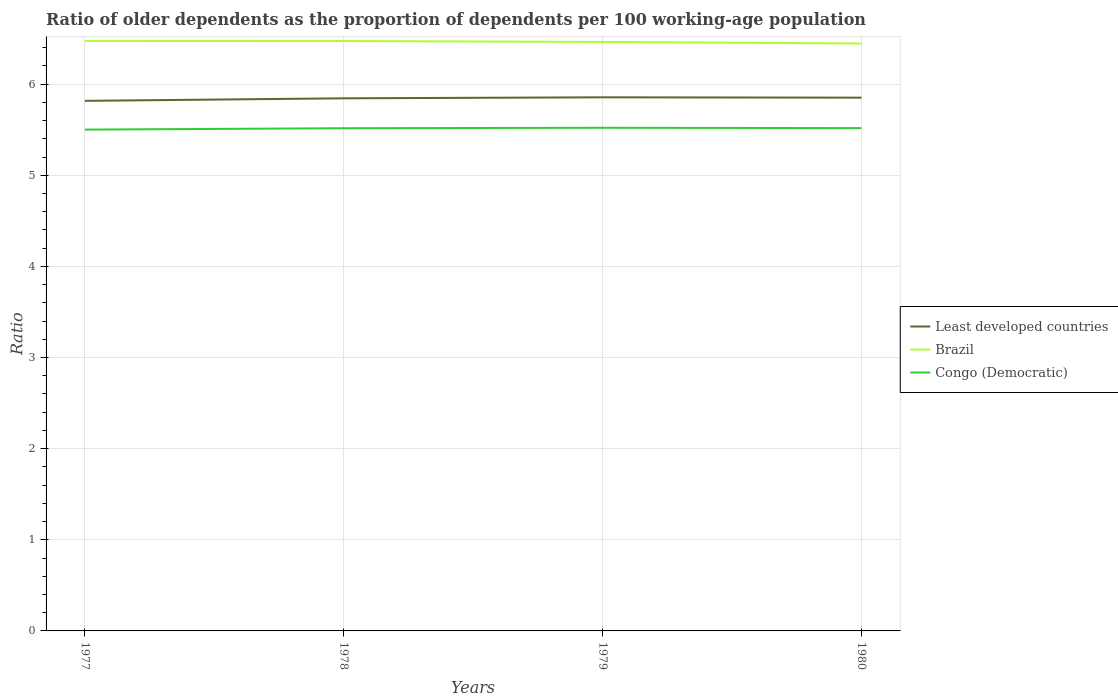How many different coloured lines are there?
Make the answer very short. 3. Across all years, what is the maximum age dependency ratio(old) in Least developed countries?
Ensure brevity in your answer.  5.82. What is the total age dependency ratio(old) in Least developed countries in the graph?
Give a very brief answer. -0.01. What is the difference between the highest and the second highest age dependency ratio(old) in Congo (Democratic)?
Give a very brief answer. 0.02. How many lines are there?
Your answer should be compact. 3. Are the values on the major ticks of Y-axis written in scientific E-notation?
Keep it short and to the point. No. Does the graph contain grids?
Offer a terse response. Yes. What is the title of the graph?
Your answer should be very brief. Ratio of older dependents as the proportion of dependents per 100 working-age population. What is the label or title of the Y-axis?
Provide a succinct answer. Ratio. What is the Ratio of Least developed countries in 1977?
Ensure brevity in your answer.  5.82. What is the Ratio in Brazil in 1977?
Ensure brevity in your answer.  6.47. What is the Ratio in Congo (Democratic) in 1977?
Your response must be concise. 5.5. What is the Ratio in Least developed countries in 1978?
Your answer should be very brief. 5.84. What is the Ratio in Brazil in 1978?
Your response must be concise. 6.47. What is the Ratio in Congo (Democratic) in 1978?
Keep it short and to the point. 5.52. What is the Ratio in Least developed countries in 1979?
Make the answer very short. 5.86. What is the Ratio of Brazil in 1979?
Give a very brief answer. 6.46. What is the Ratio in Congo (Democratic) in 1979?
Your response must be concise. 5.52. What is the Ratio of Least developed countries in 1980?
Provide a short and direct response. 5.85. What is the Ratio in Brazil in 1980?
Provide a short and direct response. 6.45. What is the Ratio in Congo (Democratic) in 1980?
Keep it short and to the point. 5.52. Across all years, what is the maximum Ratio of Least developed countries?
Offer a terse response. 5.86. Across all years, what is the maximum Ratio in Brazil?
Ensure brevity in your answer.  6.47. Across all years, what is the maximum Ratio in Congo (Democratic)?
Offer a very short reply. 5.52. Across all years, what is the minimum Ratio of Least developed countries?
Offer a very short reply. 5.82. Across all years, what is the minimum Ratio in Brazil?
Give a very brief answer. 6.45. Across all years, what is the minimum Ratio in Congo (Democratic)?
Your response must be concise. 5.5. What is the total Ratio of Least developed countries in the graph?
Offer a terse response. 23.37. What is the total Ratio of Brazil in the graph?
Keep it short and to the point. 25.86. What is the total Ratio in Congo (Democratic) in the graph?
Give a very brief answer. 22.06. What is the difference between the Ratio in Least developed countries in 1977 and that in 1978?
Make the answer very short. -0.03. What is the difference between the Ratio of Brazil in 1977 and that in 1978?
Keep it short and to the point. 0. What is the difference between the Ratio of Congo (Democratic) in 1977 and that in 1978?
Keep it short and to the point. -0.02. What is the difference between the Ratio in Least developed countries in 1977 and that in 1979?
Provide a succinct answer. -0.04. What is the difference between the Ratio of Brazil in 1977 and that in 1979?
Provide a short and direct response. 0.01. What is the difference between the Ratio in Congo (Democratic) in 1977 and that in 1979?
Provide a succinct answer. -0.02. What is the difference between the Ratio in Least developed countries in 1977 and that in 1980?
Make the answer very short. -0.04. What is the difference between the Ratio of Brazil in 1977 and that in 1980?
Keep it short and to the point. 0.03. What is the difference between the Ratio of Congo (Democratic) in 1977 and that in 1980?
Keep it short and to the point. -0.02. What is the difference between the Ratio of Least developed countries in 1978 and that in 1979?
Your answer should be very brief. -0.01. What is the difference between the Ratio of Brazil in 1978 and that in 1979?
Offer a terse response. 0.01. What is the difference between the Ratio of Congo (Democratic) in 1978 and that in 1979?
Offer a terse response. -0. What is the difference between the Ratio in Least developed countries in 1978 and that in 1980?
Your answer should be very brief. -0.01. What is the difference between the Ratio of Brazil in 1978 and that in 1980?
Provide a succinct answer. 0.03. What is the difference between the Ratio of Congo (Democratic) in 1978 and that in 1980?
Your response must be concise. -0. What is the difference between the Ratio of Least developed countries in 1979 and that in 1980?
Keep it short and to the point. 0. What is the difference between the Ratio of Brazil in 1979 and that in 1980?
Provide a short and direct response. 0.02. What is the difference between the Ratio in Congo (Democratic) in 1979 and that in 1980?
Your answer should be compact. 0. What is the difference between the Ratio of Least developed countries in 1977 and the Ratio of Brazil in 1978?
Make the answer very short. -0.66. What is the difference between the Ratio in Least developed countries in 1977 and the Ratio in Congo (Democratic) in 1978?
Provide a short and direct response. 0.3. What is the difference between the Ratio of Least developed countries in 1977 and the Ratio of Brazil in 1979?
Keep it short and to the point. -0.65. What is the difference between the Ratio in Least developed countries in 1977 and the Ratio in Congo (Democratic) in 1979?
Offer a very short reply. 0.3. What is the difference between the Ratio of Brazil in 1977 and the Ratio of Congo (Democratic) in 1979?
Your response must be concise. 0.95. What is the difference between the Ratio in Least developed countries in 1977 and the Ratio in Brazil in 1980?
Provide a succinct answer. -0.63. What is the difference between the Ratio of Least developed countries in 1977 and the Ratio of Congo (Democratic) in 1980?
Your response must be concise. 0.3. What is the difference between the Ratio of Brazil in 1977 and the Ratio of Congo (Democratic) in 1980?
Offer a terse response. 0.96. What is the difference between the Ratio of Least developed countries in 1978 and the Ratio of Brazil in 1979?
Offer a terse response. -0.62. What is the difference between the Ratio in Least developed countries in 1978 and the Ratio in Congo (Democratic) in 1979?
Provide a succinct answer. 0.32. What is the difference between the Ratio in Brazil in 1978 and the Ratio in Congo (Democratic) in 1979?
Offer a very short reply. 0.95. What is the difference between the Ratio of Least developed countries in 1978 and the Ratio of Brazil in 1980?
Keep it short and to the point. -0.6. What is the difference between the Ratio in Least developed countries in 1978 and the Ratio in Congo (Democratic) in 1980?
Provide a succinct answer. 0.33. What is the difference between the Ratio in Brazil in 1978 and the Ratio in Congo (Democratic) in 1980?
Offer a very short reply. 0.96. What is the difference between the Ratio in Least developed countries in 1979 and the Ratio in Brazil in 1980?
Keep it short and to the point. -0.59. What is the difference between the Ratio in Least developed countries in 1979 and the Ratio in Congo (Democratic) in 1980?
Provide a succinct answer. 0.34. What is the difference between the Ratio of Brazil in 1979 and the Ratio of Congo (Democratic) in 1980?
Offer a terse response. 0.95. What is the average Ratio in Least developed countries per year?
Offer a terse response. 5.84. What is the average Ratio of Brazil per year?
Make the answer very short. 6.46. What is the average Ratio of Congo (Democratic) per year?
Offer a terse response. 5.51. In the year 1977, what is the difference between the Ratio of Least developed countries and Ratio of Brazil?
Ensure brevity in your answer.  -0.66. In the year 1977, what is the difference between the Ratio of Least developed countries and Ratio of Congo (Democratic)?
Your response must be concise. 0.32. In the year 1977, what is the difference between the Ratio in Brazil and Ratio in Congo (Democratic)?
Your answer should be compact. 0.97. In the year 1978, what is the difference between the Ratio in Least developed countries and Ratio in Brazil?
Offer a terse response. -0.63. In the year 1978, what is the difference between the Ratio of Least developed countries and Ratio of Congo (Democratic)?
Keep it short and to the point. 0.33. In the year 1978, what is the difference between the Ratio in Brazil and Ratio in Congo (Democratic)?
Your response must be concise. 0.96. In the year 1979, what is the difference between the Ratio in Least developed countries and Ratio in Brazil?
Your answer should be compact. -0.61. In the year 1979, what is the difference between the Ratio of Least developed countries and Ratio of Congo (Democratic)?
Your answer should be very brief. 0.33. In the year 1979, what is the difference between the Ratio in Brazil and Ratio in Congo (Democratic)?
Offer a very short reply. 0.94. In the year 1980, what is the difference between the Ratio of Least developed countries and Ratio of Brazil?
Offer a very short reply. -0.59. In the year 1980, what is the difference between the Ratio of Least developed countries and Ratio of Congo (Democratic)?
Provide a succinct answer. 0.33. In the year 1980, what is the difference between the Ratio in Brazil and Ratio in Congo (Democratic)?
Keep it short and to the point. 0.93. What is the ratio of the Ratio of Brazil in 1977 to that in 1978?
Keep it short and to the point. 1. What is the ratio of the Ratio in Congo (Democratic) in 1977 to that in 1978?
Provide a short and direct response. 1. What is the ratio of the Ratio in Least developed countries in 1977 to that in 1979?
Offer a terse response. 0.99. What is the ratio of the Ratio of Least developed countries in 1977 to that in 1980?
Keep it short and to the point. 0.99. What is the ratio of the Ratio of Brazil in 1977 to that in 1980?
Offer a very short reply. 1. What is the ratio of the Ratio in Congo (Democratic) in 1977 to that in 1980?
Provide a succinct answer. 1. What is the ratio of the Ratio in Least developed countries in 1978 to that in 1979?
Make the answer very short. 1. What is the ratio of the Ratio in Brazil in 1978 to that in 1979?
Your answer should be very brief. 1. What is the ratio of the Ratio of Congo (Democratic) in 1978 to that in 1979?
Provide a succinct answer. 1. What is the ratio of the Ratio in Brazil in 1978 to that in 1980?
Offer a very short reply. 1. What is the ratio of the Ratio in Least developed countries in 1979 to that in 1980?
Make the answer very short. 1. What is the ratio of the Ratio in Brazil in 1979 to that in 1980?
Your answer should be compact. 1. What is the difference between the highest and the second highest Ratio of Least developed countries?
Your answer should be compact. 0. What is the difference between the highest and the second highest Ratio in Brazil?
Provide a short and direct response. 0. What is the difference between the highest and the second highest Ratio in Congo (Democratic)?
Offer a terse response. 0. What is the difference between the highest and the lowest Ratio of Least developed countries?
Keep it short and to the point. 0.04. What is the difference between the highest and the lowest Ratio in Brazil?
Provide a succinct answer. 0.03. What is the difference between the highest and the lowest Ratio of Congo (Democratic)?
Offer a very short reply. 0.02. 